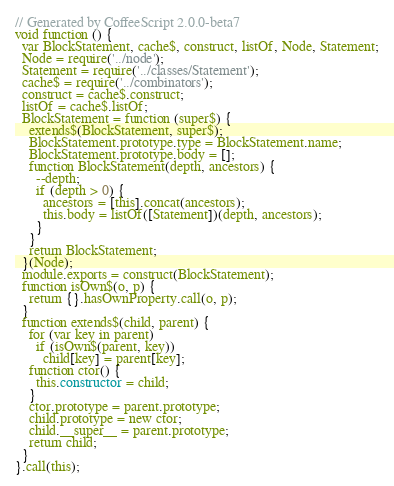<code> <loc_0><loc_0><loc_500><loc_500><_JavaScript_>// Generated by CoffeeScript 2.0.0-beta7
void function () {
  var BlockStatement, cache$, construct, listOf, Node, Statement;
  Node = require('../node');
  Statement = require('../classes/Statement');
  cache$ = require('../combinators');
  construct = cache$.construct;
  listOf = cache$.listOf;
  BlockStatement = function (super$) {
    extends$(BlockStatement, super$);
    BlockStatement.prototype.type = BlockStatement.name;
    BlockStatement.prototype.body = [];
    function BlockStatement(depth, ancestors) {
      --depth;
      if (depth > 0) {
        ancestors = [this].concat(ancestors);
        this.body = listOf([Statement])(depth, ancestors);
      }
    }
    return BlockStatement;
  }(Node);
  module.exports = construct(BlockStatement);
  function isOwn$(o, p) {
    return {}.hasOwnProperty.call(o, p);
  }
  function extends$(child, parent) {
    for (var key in parent)
      if (isOwn$(parent, key))
        child[key] = parent[key];
    function ctor() {
      this.constructor = child;
    }
    ctor.prototype = parent.prototype;
    child.prototype = new ctor;
    child.__super__ = parent.prototype;
    return child;
  }
}.call(this);
</code> 